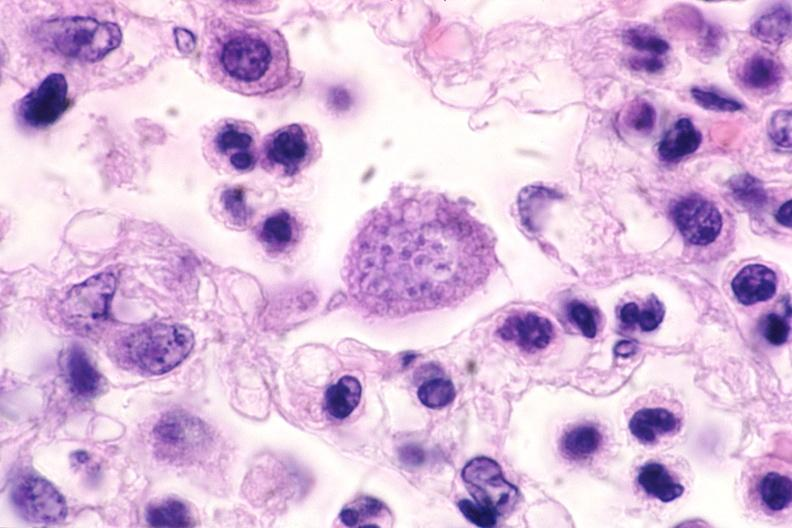does this image show touch impression from brain, toxoplasma cyst?
Answer the question using a single word or phrase. Yes 